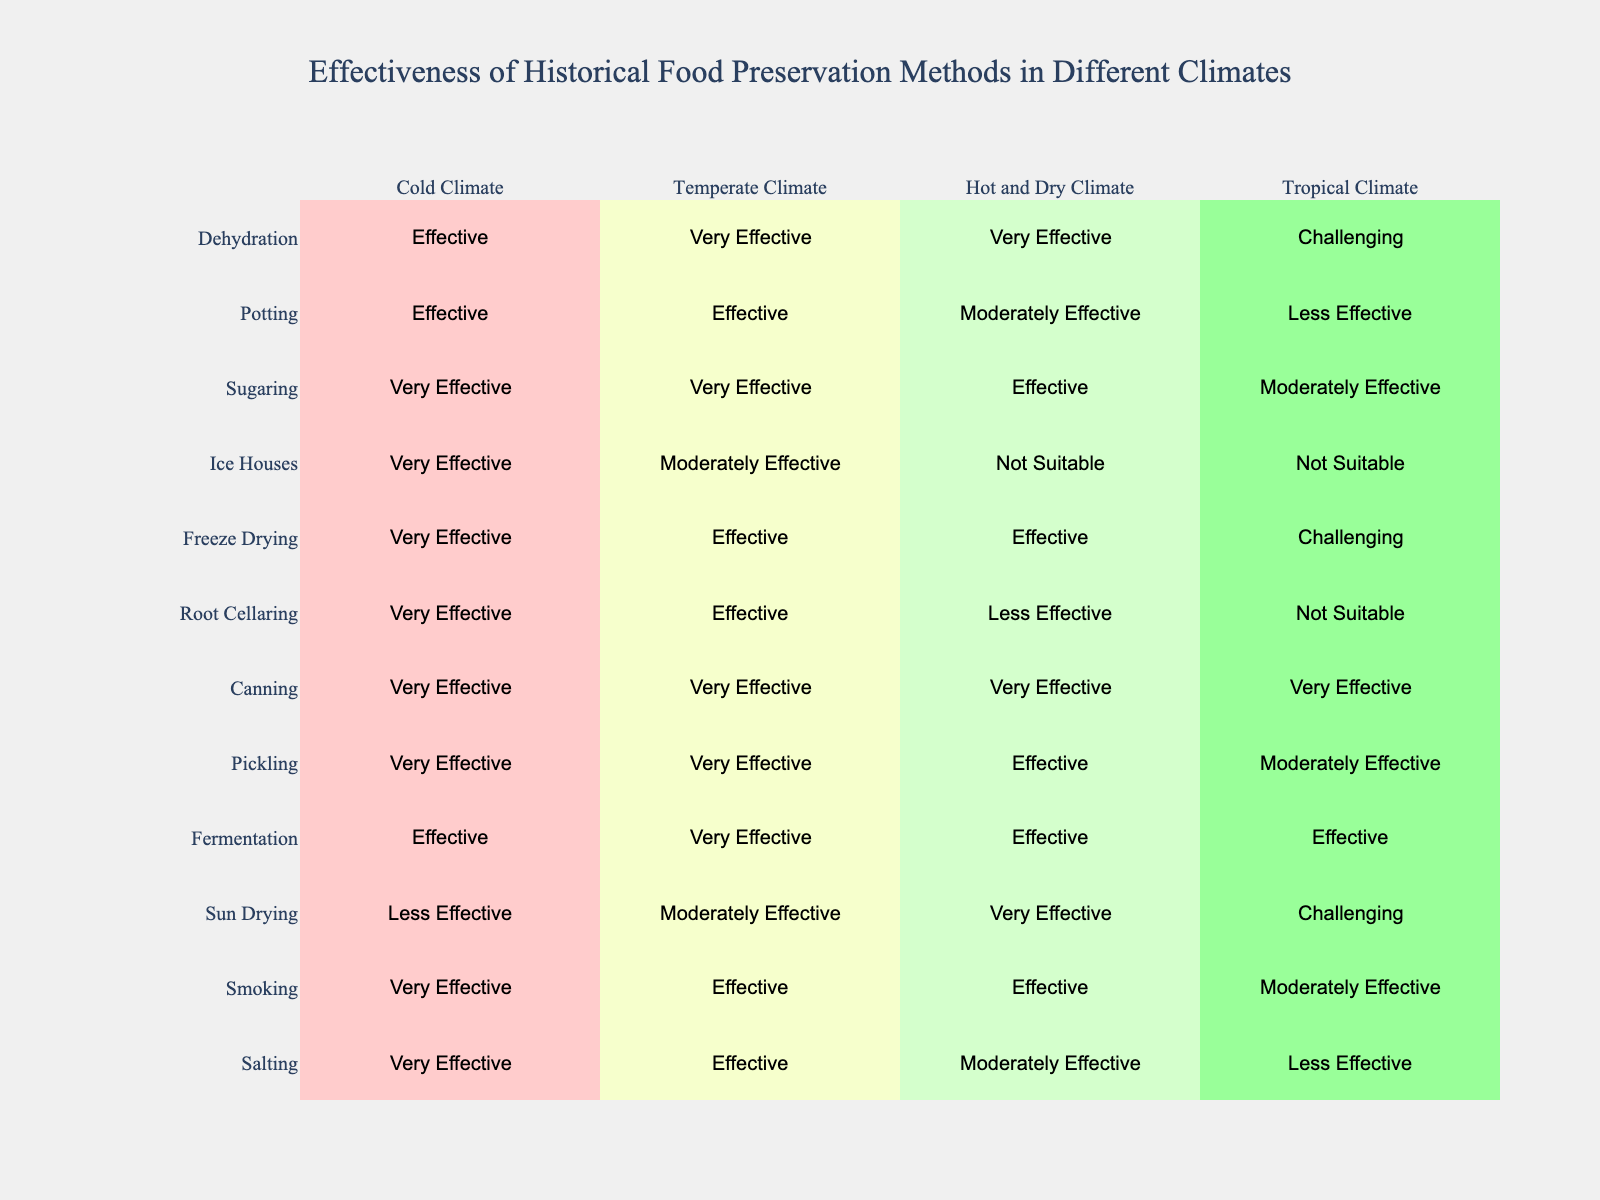What food preservation method is the least effective in a tropical climate? Looking at the table, the only method rated as "Challenging" for tropical climates is sun drying. Therefore, it is considered the least effective in that climate.
Answer: Sun drying Which preservation method is very effective across all climate types? By examining the table, we can see that canning maintains a "Very Effective" status in cold, temperate, hot and dry, and tropical climates.
Answer: Canning Are there any preservation methods that are not suitable for hot and dry climates? According to the table, ice houses and root cellaring are marked as "Not Suitable" for hot and dry climates. Thus, the answer is yes.
Answer: Yes Which method shows a decline in effectiveness from cold to tropical climates? By comparing the ratings for each method, we notice that root cellaring transitions from "Very Effective" in cold climates to "Not Suitable" in tropical climates, indicating a decline in effectiveness.
Answer: Root cellaring How many preservation methods are effective in temperate climates? Counting the "Effective" ratings in temperate climates, we find that 7 methods are listed as "Effective" or better, namely smoking, fermentation, pickling, canning, potting, and dehydrating.
Answer: 7 Is smoking more effective than fermentation in tropical climates? According to the table, smoking is rated as "Moderately Effective," while fermentation is "Effective" in tropical climates. This suggests that smoking is not more effective than fermentation in that climate.
Answer: No What is the average effectiveness rating of the preservation methods in a cold climate? Converting the qualitative ratings to a numerical system (Very Effective=4, Effective=3, Moderately Effective=2, Less Effective=1, Not Suitable=0), the calculations yield: (4 + 4 + 3 + 4 + 4 + 4 + 4 + 4 + 4 + 3 + 3 + 3 + 3 + 4 + 4) / 15 = 3.4 on average. Therefore, the average is roughly 3.4, classified as "Effective."
Answer: 3.4 Which method is considered the most effective for hot and dry climates? Referring to the table, sun drying is rated as "Very Effective" in hot and dry climates, making it the most effective method in that setting.
Answer: Sun drying Do tropical climates benefit from the same preservation methods as cold climates? Analyzing the effectiveness ratings, certain methods like salting decline in effectiveness from cold to tropical, indicating that they do not benefit equally in both climates.
Answer: No 